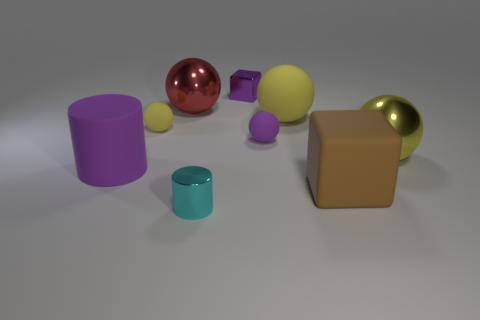There is a big yellow sphere on the left side of the yellow metallic thing; what is it made of?
Provide a short and direct response. Rubber. Are the cube behind the rubber block and the brown object made of the same material?
Give a very brief answer. No. There is a yellow metal thing that is the same size as the brown matte thing; what is its shape?
Your answer should be very brief. Sphere. How many rubber objects have the same color as the small cube?
Offer a very short reply. 2. Are there fewer small purple objects that are to the left of the cyan metallic thing than small purple rubber objects left of the large red shiny sphere?
Provide a succinct answer. No. There is a small yellow sphere; are there any small blocks in front of it?
Your answer should be compact. No. There is a small sphere right of the purple thing that is behind the tiny yellow object; are there any shiny cylinders on the right side of it?
Your answer should be very brief. No. There is a big yellow object to the right of the large yellow matte thing; is its shape the same as the cyan object?
Your answer should be very brief. No. What color is the small block that is the same material as the large red ball?
Keep it short and to the point. Purple. What number of purple things have the same material as the small yellow sphere?
Offer a terse response. 2. 